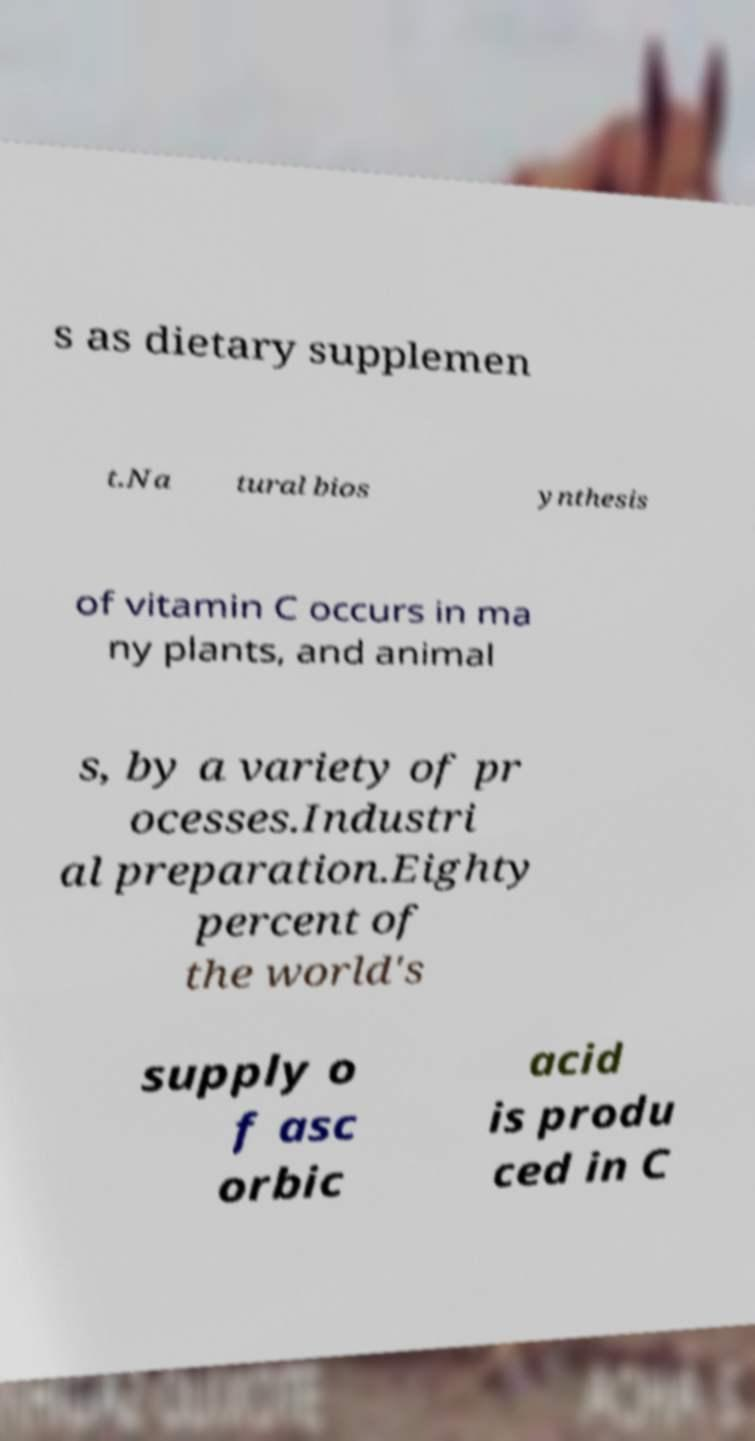Could you extract and type out the text from this image? s as dietary supplemen t.Na tural bios ynthesis of vitamin C occurs in ma ny plants, and animal s, by a variety of pr ocesses.Industri al preparation.Eighty percent of the world's supply o f asc orbic acid is produ ced in C 